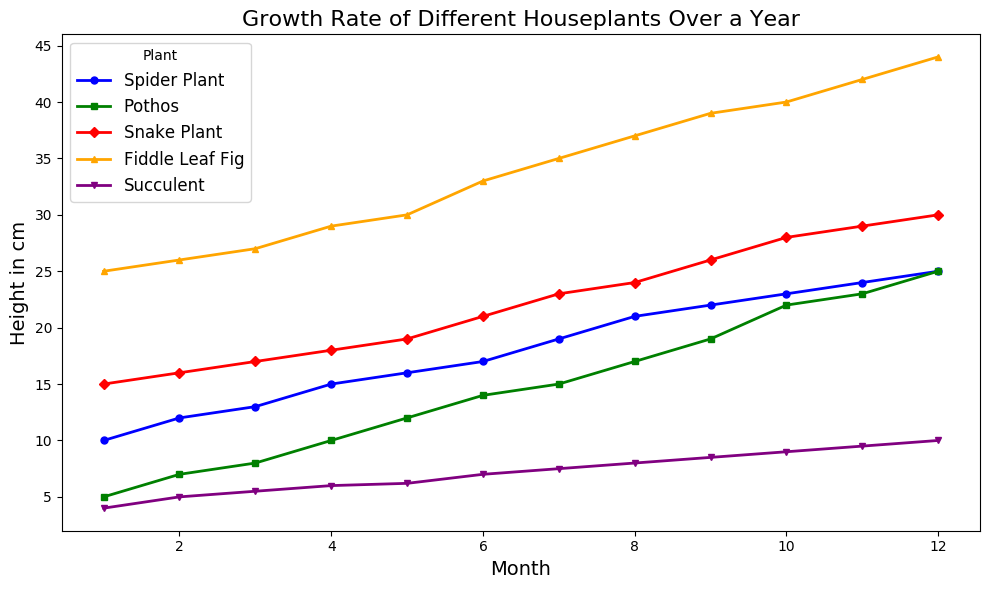What month shows the most significant growth in Spider Plant height? In the figure, observe the slope of the line marking the height growth of the Spider Plant. The steeper the slope, the more significant the growth in that month. Between months 7 and 8, the height increases from 19 to 21 cm, showing the most significant growth of 2 cm.
Answer: Between months 7 and 8 Which plant has the greatest overall height increase from month 1 to month 12? By comparing the starting and ending heights of each plant in the figure, calculate the difference. For Spider Plant: 25-10=15 cm, Pothos: 25-5=20 cm, Snake Plant: 30-15=15 cm, Fiddle Leaf Fig: 44-25=19 cm, and Succulent: 10-4=6 cm. Fiddle Leaf Fig shows the highest increase.
Answer: Fiddle Leaf Fig Between the Spider Plant and Pothos, which one grew faster in the first four months? Observe the lines of Spider Plant and Pothos in the first four months. The Spider Plant grows from 10 to 15 cm, an increase of 5 cm. The Pothos grows from 5 to 10 cm, an increase of 5 cm as well. Both grew at the same rate initially.
Answer: Both grew at the same rate What is the height of the Succulent at month 6, and how does it compare to the height of the Snake Plant at the same month? Check the line corresponding to the Succulent and Snake Plant at month 6. The height of the Succulent is 7 cm, while the Snake Plant is 21 cm. The Snake Plant is significantly taller in that month.
Answer: Snake Plant is taller; Succulent is 7 cm, Snake Plant is 21 cm Which plant had the least variation in height over the year? Examine the total increase in height for each plant from month 1 to month 12. The Spider Plant grows from 10 to 25 cm, Pothos grows from 5 to 25 cm, Snake Plant grows from 15 to 30 cm, Fiddle Leaf Fig grows from 25 to 44 cm, and Succulent grows from 4 to 10 cm. The Succulent has the smallest increase of 6 cm, indicating the least variation.
Answer: Succulent How much taller is the Fiddle Leaf Fig than the Snake Plant at month 12? Check the heights of Fiddle Leaf Fig and Snake Plant at month 12 from the figure. The Fiddle Leaf Fig is 44 cm tall, while the Snake Plant is 30 cm tall. The difference in height is 44 - 30 = 14 cm.
Answer: 14 cm If we consider the average growth per month, which plant had the highest average growth rate? Calculate the total height increase for each plant and divide by 12 (the number of months). Spider Plant: (25-10)/12 = 1.25 cm/month, Pothos: (25-5)/12 = 1.67 cm/month, Snake Plant: (30-15)/12 = 1.25 cm/month, Fiddle Leaf Fig: (44-25)/12 = 1.58 cm/month, Succulent: (10-4)/12 = 0.50 cm/month. Pothos has the highest average growth rate.
Answer: Pothos Which plant reached a height of 20 cm first, and in which month? Scan the lines and find the exact month when each plant reaches or exceeds 20 cm. Spider Plant reaches 21 cm in month 8, Pothos reaches 22 cm in month 10, Snake Plant exceeds 20 cm in month 7, Fiddle Leaf Fig is already above 20 cm, and Succulent doesn't reach 20 cm within the year. The Snake Plant hits that mark first in month 7.
Answer: Snake Plant, Month 7 